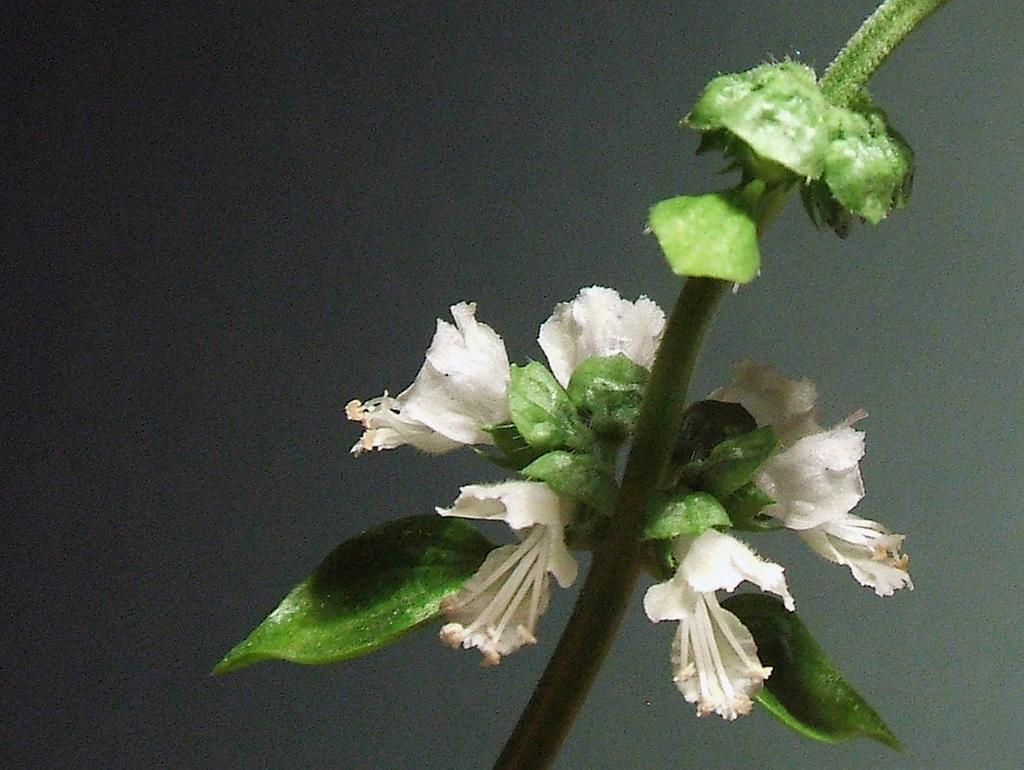What is the main subject of the image? The main subject of the image is a stem with flowers. Are there any additional features on the stem? Yes, there are leaves on the stem. What can be observed about the background of the image? The background of the image is dark. What type of beast can be seen shaking hands with someone in the image? There is no beast or handshake present in the image; it features a stem with flowers and leaves. What method of payment is accepted for the flowers in the image? There is no indication of payment in the image, as it only shows a stem with flowers and leaves. 